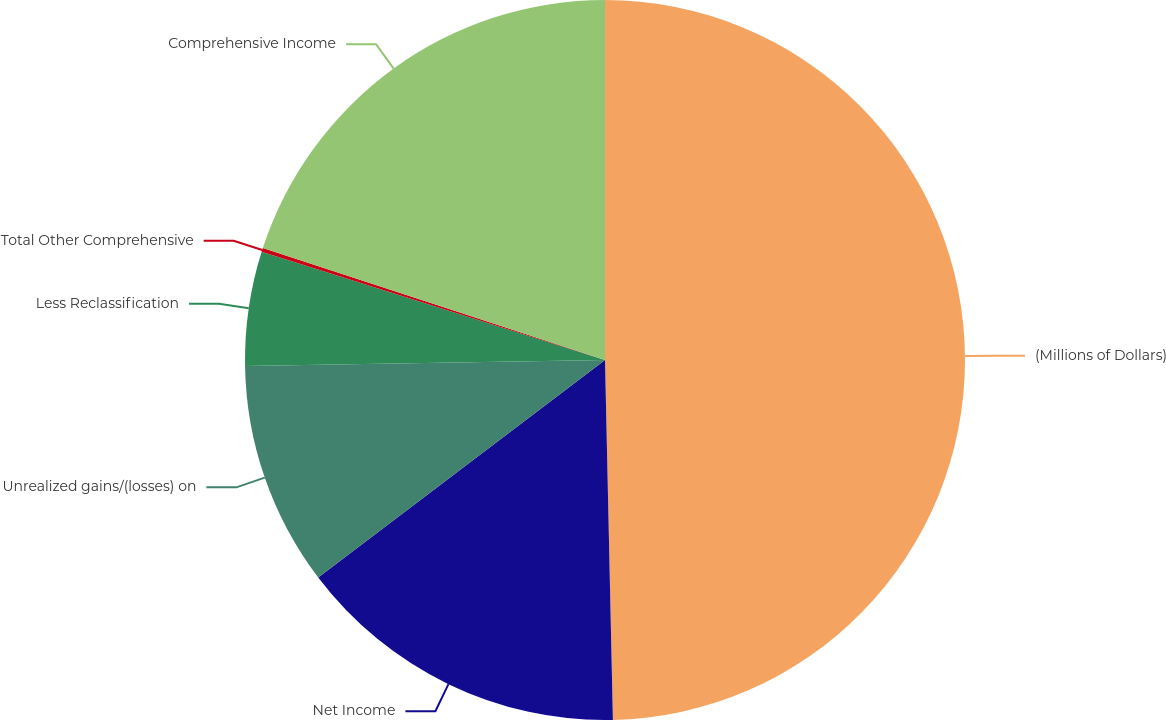<chart> <loc_0><loc_0><loc_500><loc_500><pie_chart><fcel>(Millions of Dollars)<fcel>Net Income<fcel>Unrealized gains/(losses) on<fcel>Less Reclassification<fcel>Total Other Comprehensive<fcel>Comprehensive Income<nl><fcel>49.65%<fcel>15.02%<fcel>10.07%<fcel>5.12%<fcel>0.17%<fcel>19.97%<nl></chart> 